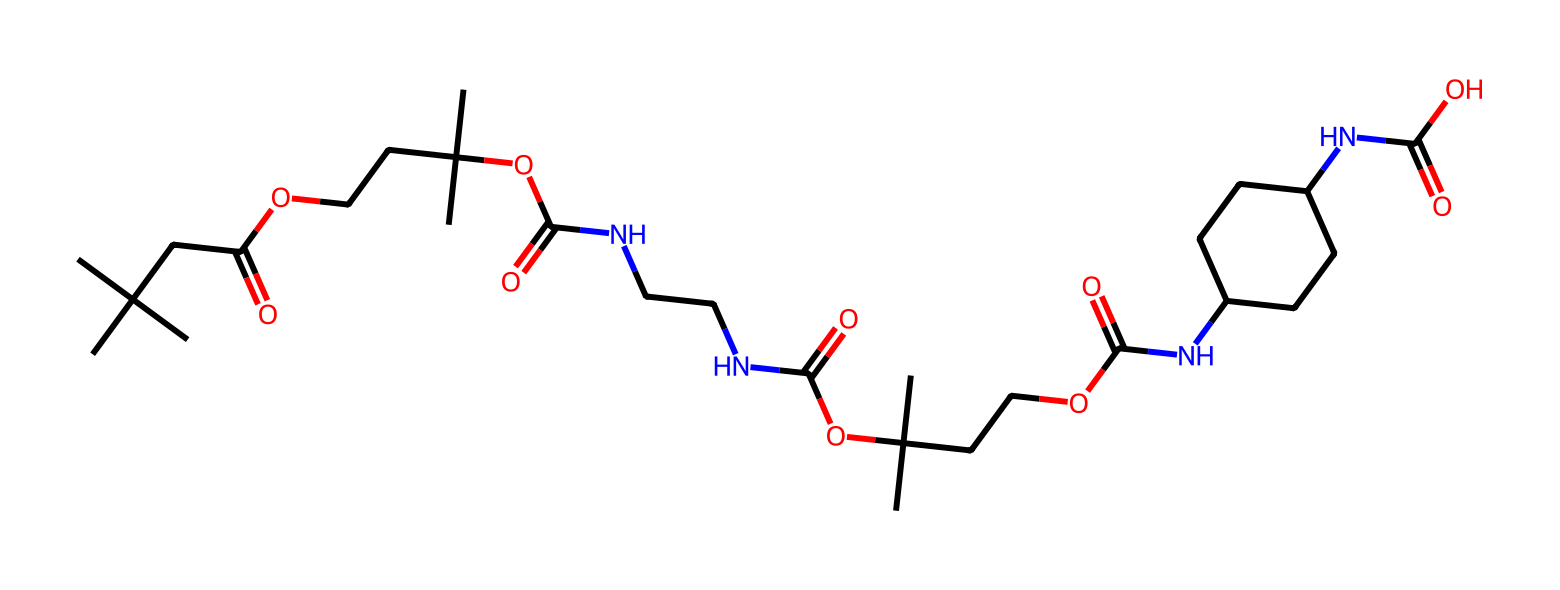What is the total number of carbon atoms in this chemical? By examining the SMILES representation, we can count the carbon atoms represented by 'C'. In the given SMILES, there are 27 carbon atoms.
Answer: 27 How many nitrogen atoms are present in the molecule? In the SMILES representation, 'N' indicates the presence of nitrogen atoms. By scanning through the chemical structure, we find there are 4 nitrogen atoms in total.
Answer: 4 What type of functional groups can be identified in this chemical? The SMILES includes parts representing carboxylic acids (indicated by 'O=C-O'), amides (indicated by 'O=C-N'), and ethers (indicated by 'O-C'). These functional groups contribute to its properties.
Answer: carboxylic acids, amides, ethers What is the molecular weight of this polyurethane compound? To determine the molecular weight, we calculate the contribution of each atom: Carbon = 12.01 g/mol, Hydrogen = 1.008 g/mol, Nitrogen = 14.01 g/mol, and Oxygen = 16.00 g/mol. After performing the calculations based on the number of each atom (C, H, N, O), we find the molecular weight is approximately 500 g/mol.
Answer: 500 g/mol Is this chemical likely to be soluble in water? Non-electrolytes, like this polyurethane, typically do not dissociate into ions in solution. However, due to the presence of polar functional groups (like -OH and -COOH), it might exhibit some degree of solubility but not high. The overall properties still lean towards being insoluble.
Answer: low solubility What role do the nitrogen atoms play in this polyurethane structure? The nitrogen atoms in the SMILES represent amide linkages that contribute to the structure's functionality, potentially affecting the strength, elasticity, and durability of the polyurethane material used in basketballs.
Answer: structural functionality 